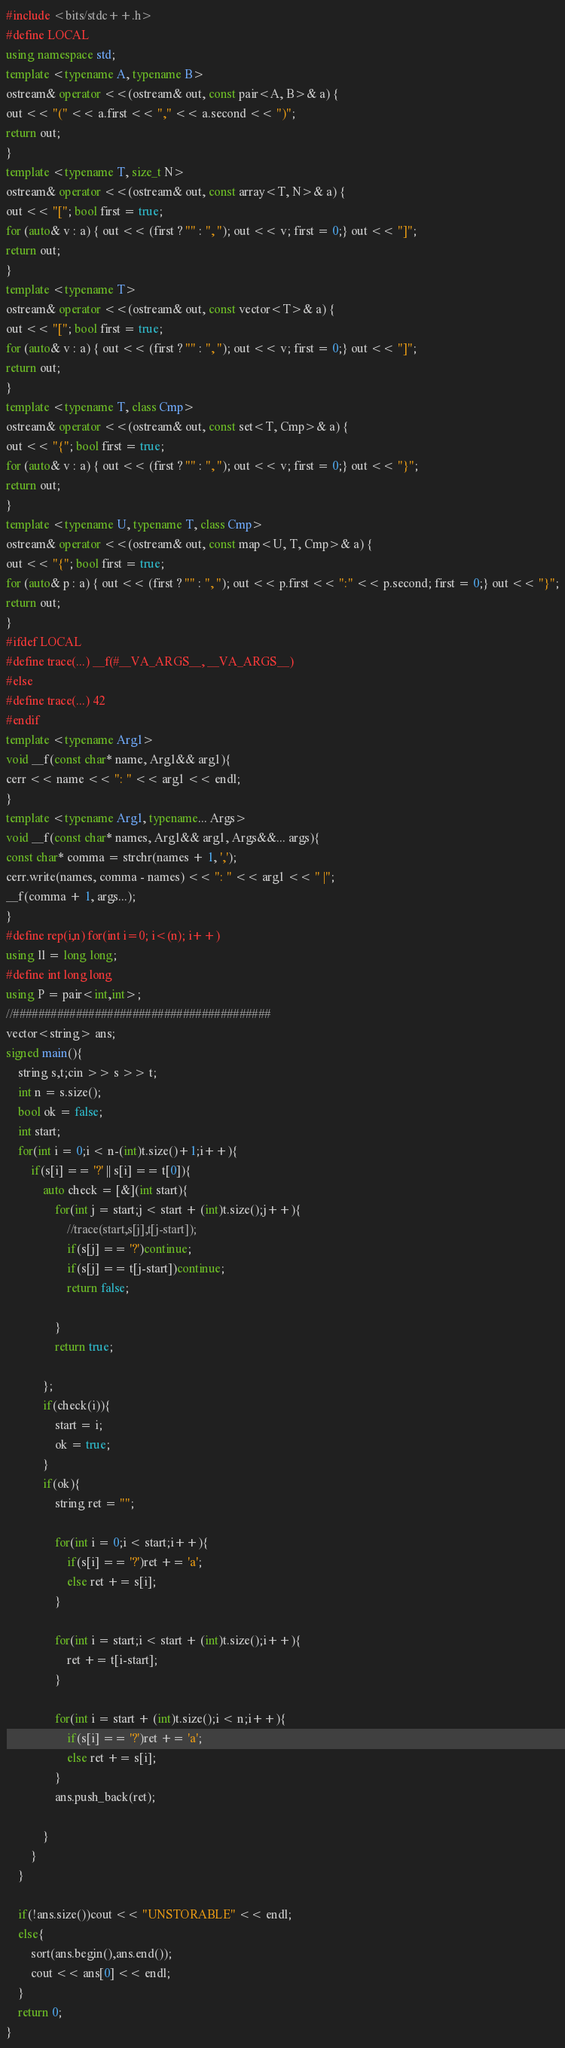Convert code to text. <code><loc_0><loc_0><loc_500><loc_500><_C++_>#include <bits/stdc++.h>
#define LOCAL
using namespace std;
template <typename A, typename B>
ostream& operator <<(ostream& out, const pair<A, B>& a) {
out << "(" << a.first << "," << a.second << ")";
return out;
}
template <typename T, size_t N>
ostream& operator <<(ostream& out, const array<T, N>& a) {
out << "["; bool first = true;
for (auto& v : a) { out << (first ? "" : ", "); out << v; first = 0;} out << "]";
return out;
}
template <typename T>
ostream& operator <<(ostream& out, const vector<T>& a) {
out << "["; bool first = true;
for (auto& v : a) { out << (first ? "" : ", "); out << v; first = 0;} out << "]";
return out;
}
template <typename T, class Cmp>
ostream& operator <<(ostream& out, const set<T, Cmp>& a) {
out << "{"; bool first = true;
for (auto& v : a) { out << (first ? "" : ", "); out << v; first = 0;} out << "}";
return out;
}
template <typename U, typename T, class Cmp>
ostream& operator <<(ostream& out, const map<U, T, Cmp>& a) {
out << "{"; bool first = true;
for (auto& p : a) { out << (first ? "" : ", "); out << p.first << ":" << p.second; first = 0;} out << "}";
return out;
}
#ifdef LOCAL
#define trace(...) __f(#__VA_ARGS__, __VA_ARGS__)
#else
#define trace(...) 42
#endif
template <typename Arg1>
void __f(const char* name, Arg1&& arg1){
cerr << name << ": " << arg1 << endl;
}
template <typename Arg1, typename... Args>
void __f(const char* names, Arg1&& arg1, Args&&... args){
const char* comma = strchr(names + 1, ',');
cerr.write(names, comma - names) << ": " << arg1 << " |";
__f(comma + 1, args...);
}
#define rep(i,n) for(int i=0; i<(n); i++)
using ll = long long;
#define int long long
using P = pair<int,int>;
//#########################################
vector<string> ans;
signed main(){
    string s,t;cin >> s >> t;
    int n = s.size();
    bool ok = false;
    int start;
    for(int i = 0;i < n-(int)t.size()+1;i++){
        if(s[i] == '?' || s[i] == t[0]){
            auto check = [&](int start){
                for(int j = start;j < start + (int)t.size();j++){
                    //trace(start,s[j],t[j-start]);
                    if(s[j] == '?')continue;
                    if(s[j] == t[j-start])continue;
                    return false;

                }
                return true;

            };
            if(check(i)){
                start = i;
                ok = true;
            }
            if(ok){
                string ret = "";
                
                for(int i = 0;i < start;i++){
                    if(s[i] == '?')ret += 'a';
                    else ret += s[i];
                }
                
                for(int i = start;i < start + (int)t.size();i++){
                    ret += t[i-start];
                }
                
                for(int i = start + (int)t.size();i < n;i++){
                    if(s[i] == '?')ret += 'a';
                    else ret += s[i];
                }
                ans.push_back(ret);

            }
        }
    }
    
    if(!ans.size())cout << "UNSTORABLE" << endl;
    else{
        sort(ans.begin(),ans.end());
        cout << ans[0] << endl;
    }
    return 0;
}</code> 